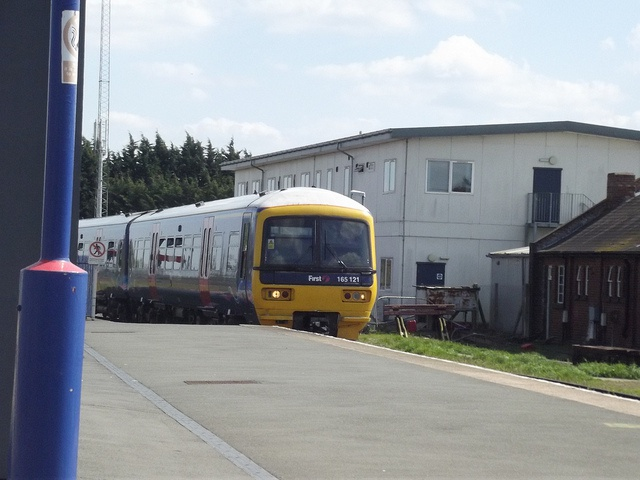Describe the objects in this image and their specific colors. I can see a train in black, gray, and darkgray tones in this image. 